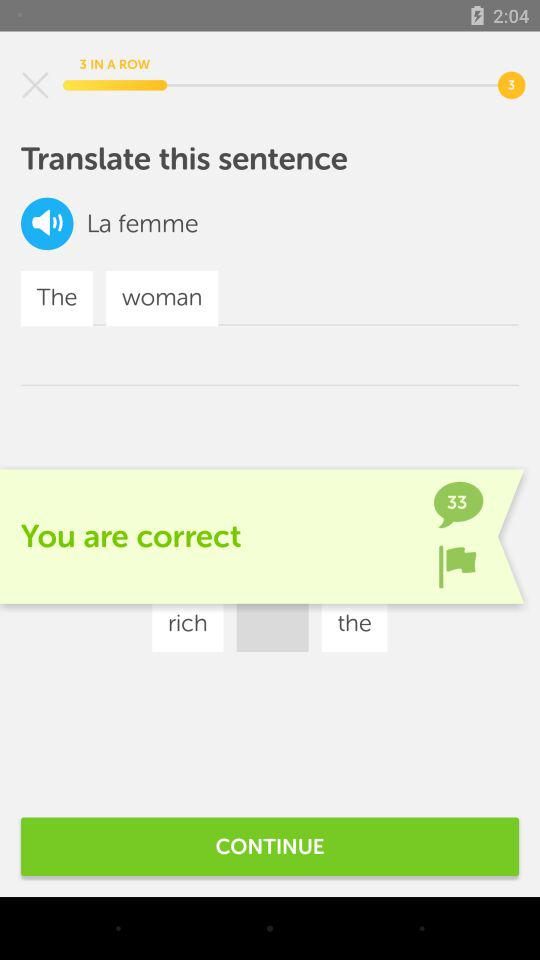Was my answer correct? Your answer was correct. 